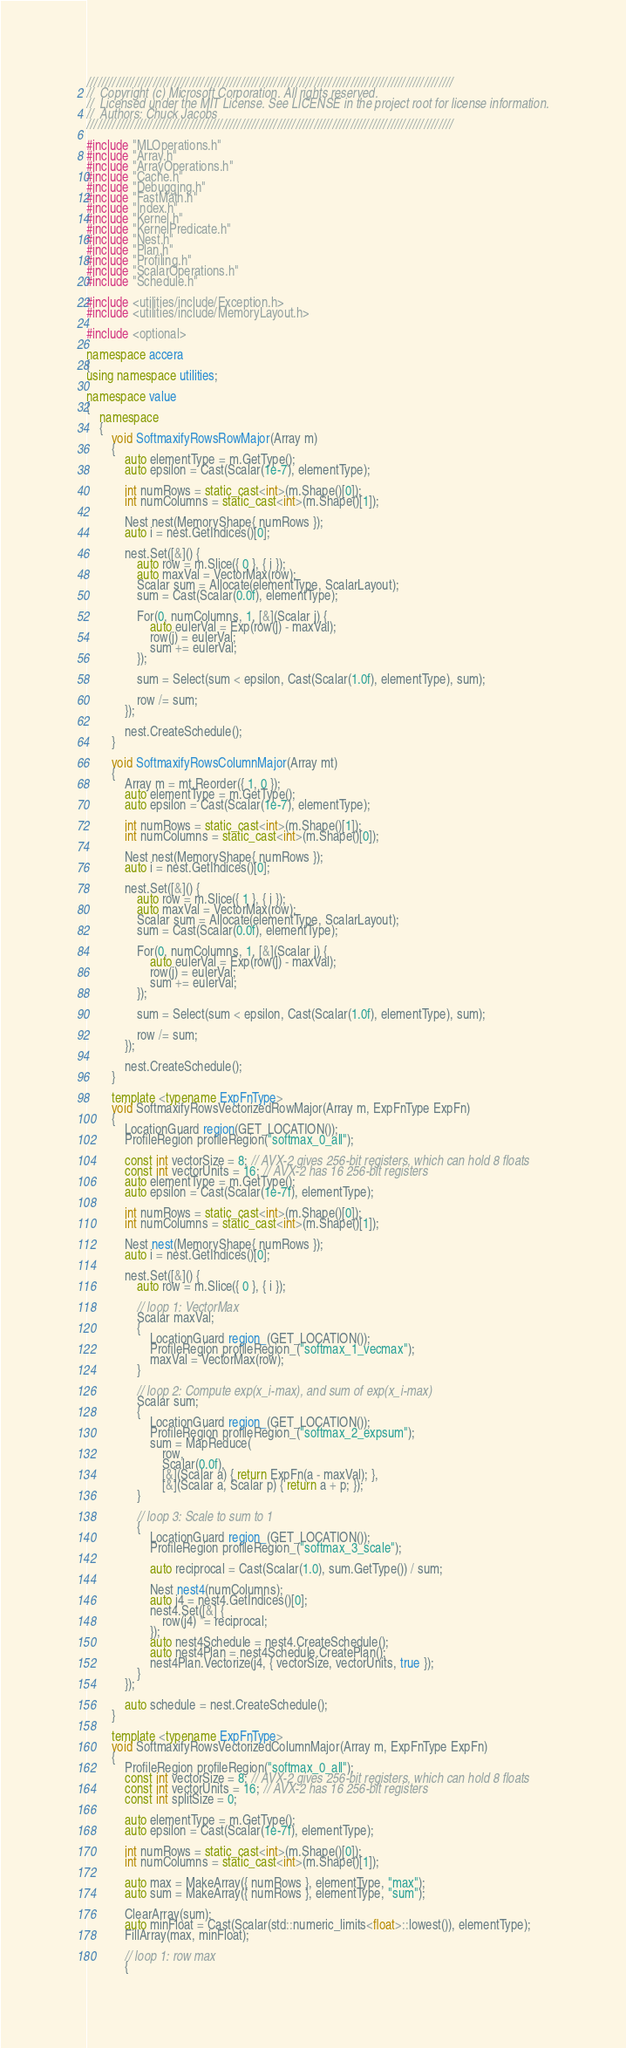<code> <loc_0><loc_0><loc_500><loc_500><_C++_>////////////////////////////////////////////////////////////////////////////////////////////////////
//  Copyright (c) Microsoft Corporation. All rights reserved.
//  Licensed under the MIT License. See LICENSE in the project root for license information.
//  Authors: Chuck Jacobs
////////////////////////////////////////////////////////////////////////////////////////////////////

#include "MLOperations.h"
#include "Array.h"
#include "ArrayOperations.h"
#include "Cache.h"
#include "Debugging.h"
#include "FastMath.h"
#include "Index.h"
#include "Kernel.h"
#include "KernelPredicate.h"
#include "Nest.h"
#include "Plan.h"
#include "Profiling.h"
#include "ScalarOperations.h"
#include "Schedule.h"

#include <utilities/include/Exception.h>
#include <utilities/include/MemoryLayout.h>

#include <optional>

namespace accera
{
using namespace utilities;

namespace value
{
    namespace
    {
        void SoftmaxifyRowsRowMajor(Array m)
        {
            auto elementType = m.GetType();
            auto epsilon = Cast(Scalar(1e-7), elementType);

            int numRows = static_cast<int>(m.Shape()[0]);
            int numColumns = static_cast<int>(m.Shape()[1]);

            Nest nest(MemoryShape{ numRows });
            auto i = nest.GetIndices()[0];

            nest.Set([&]() {
                auto row = m.Slice({ 0 }, { i });
                auto maxVal = VectorMax(row);
                Scalar sum = Allocate(elementType, ScalarLayout);
                sum = Cast(Scalar(0.0f), elementType);

                For(0, numColumns, 1, [&](Scalar j) {
                    auto eulerVal = Exp(row(j) - maxVal);
                    row(j) = eulerVal;
                    sum += eulerVal;
                });

                sum = Select(sum < epsilon, Cast(Scalar(1.0f), elementType), sum);

                row /= sum;
            });

            nest.CreateSchedule();
        }

        void SoftmaxifyRowsColumnMajor(Array mt)
        {
            Array m = mt.Reorder({ 1, 0 });
            auto elementType = m.GetType();
            auto epsilon = Cast(Scalar(1e-7), elementType);

            int numRows = static_cast<int>(m.Shape()[1]);
            int numColumns = static_cast<int>(m.Shape()[0]);

            Nest nest(MemoryShape{ numRows });
            auto i = nest.GetIndices()[0];

            nest.Set([&]() {
                auto row = m.Slice({ 1 }, { i });
                auto maxVal = VectorMax(row);
                Scalar sum = Allocate(elementType, ScalarLayout);
                sum = Cast(Scalar(0.0f), elementType);

                For(0, numColumns, 1, [&](Scalar j) {
                    auto eulerVal = Exp(row(j) - maxVal);
                    row(j) = eulerVal;
                    sum += eulerVal;
                });

                sum = Select(sum < epsilon, Cast(Scalar(1.0f), elementType), sum);

                row /= sum;
            });

            nest.CreateSchedule();
        }

        template <typename ExpFnType>
        void SoftmaxifyRowsVectorizedRowMajor(Array m, ExpFnType ExpFn)
        {
            LocationGuard region(GET_LOCATION());
            ProfileRegion profileRegion("softmax_0_all");

            const int vectorSize = 8; // AVX-2 gives 256-bit registers, which can hold 8 floats
            const int vectorUnits = 16; // AVX-2 has 16 256-bit registers
            auto elementType = m.GetType();
            auto epsilon = Cast(Scalar(1e-7f), elementType);

            int numRows = static_cast<int>(m.Shape()[0]);
            int numColumns = static_cast<int>(m.Shape()[1]);

            Nest nest(MemoryShape{ numRows });
            auto i = nest.GetIndices()[0];

            nest.Set([&]() {
                auto row = m.Slice({ 0 }, { i });

                // loop 1: VectorMax
                Scalar maxVal;
                {
                    LocationGuard region_(GET_LOCATION());
                    ProfileRegion profileRegion_("softmax_1_vecmax");
                    maxVal = VectorMax(row);
                }

                // loop 2: Compute exp(x_i-max), and sum of exp(x_i-max)
                Scalar sum;
                {
                    LocationGuard region_(GET_LOCATION());
                    ProfileRegion profileRegion_("softmax_2_expsum");
                    sum = MapReduce(
                        row,
                        Scalar(0.0f),
                        [&](Scalar a) { return ExpFn(a - maxVal); },
                        [&](Scalar a, Scalar p) { return a + p; });
                }

                // loop 3: Scale to sum to 1
                {
                    LocationGuard region_(GET_LOCATION());
                    ProfileRegion profileRegion_("softmax_3_scale");

                    auto reciprocal = Cast(Scalar(1.0), sum.GetType()) / sum;

                    Nest nest4(numColumns);
                    auto j4 = nest4.GetIndices()[0];
                    nest4.Set([&] {
                        row(j4) *= reciprocal;
                    });
                    auto nest4Schedule = nest4.CreateSchedule();
                    auto nest4Plan = nest4Schedule.CreatePlan();
                    nest4Plan.Vectorize(j4, { vectorSize, vectorUnits, true });
                }
            });

            auto schedule = nest.CreateSchedule();
        }

        template <typename ExpFnType>
        void SoftmaxifyRowsVectorizedColumnMajor(Array m, ExpFnType ExpFn)
        {
            ProfileRegion profileRegion("softmax_0_all");
            const int vectorSize = 8; // AVX-2 gives 256-bit registers, which can hold 8 floats
            const int vectorUnits = 16; // AVX-2 has 16 256-bit registers
            const int splitSize = 0;

            auto elementType = m.GetType();
            auto epsilon = Cast(Scalar(1e-7f), elementType);

            int numRows = static_cast<int>(m.Shape()[0]);
            int numColumns = static_cast<int>(m.Shape()[1]);

            auto max = MakeArray({ numRows }, elementType, "max");
            auto sum = MakeArray({ numRows }, elementType, "sum");

            ClearArray(sum);
            auto minFloat = Cast(Scalar(std::numeric_limits<float>::lowest()), elementType);
            FillArray(max, minFloat);

            // loop 1: row max
            {</code> 